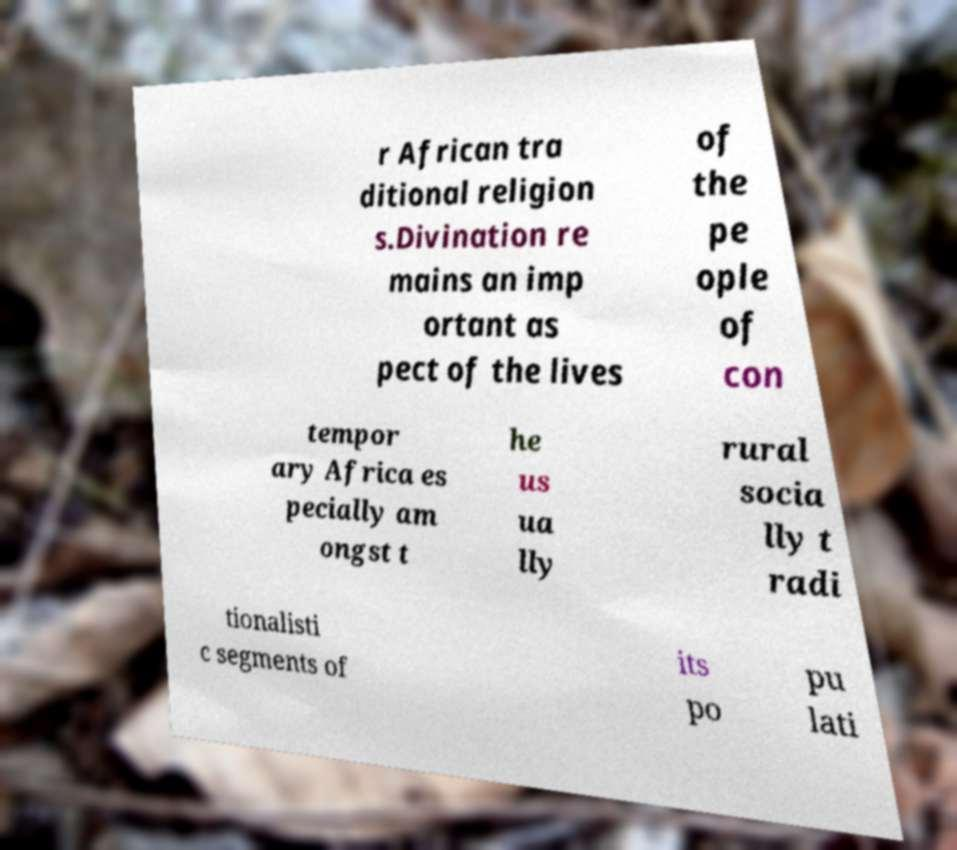What messages or text are displayed in this image? I need them in a readable, typed format. r African tra ditional religion s.Divination re mains an imp ortant as pect of the lives of the pe ople of con tempor ary Africa es pecially am ongst t he us ua lly rural socia lly t radi tionalisti c segments of its po pu lati 